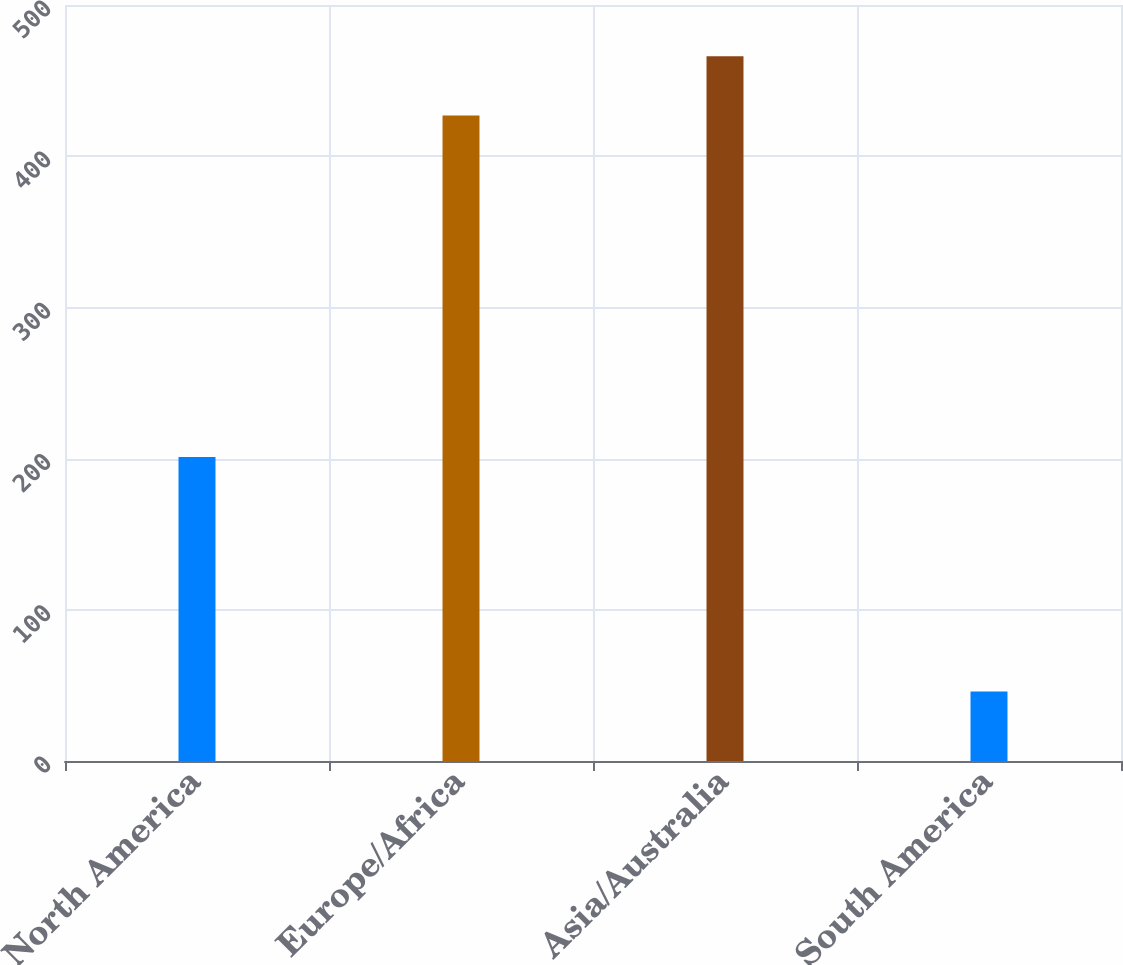<chart> <loc_0><loc_0><loc_500><loc_500><bar_chart><fcel>North America<fcel>Europe/Africa<fcel>Asia/Australia<fcel>South America<nl><fcel>201<fcel>427<fcel>466.1<fcel>46<nl></chart> 